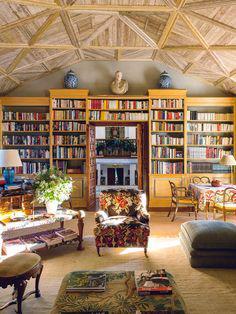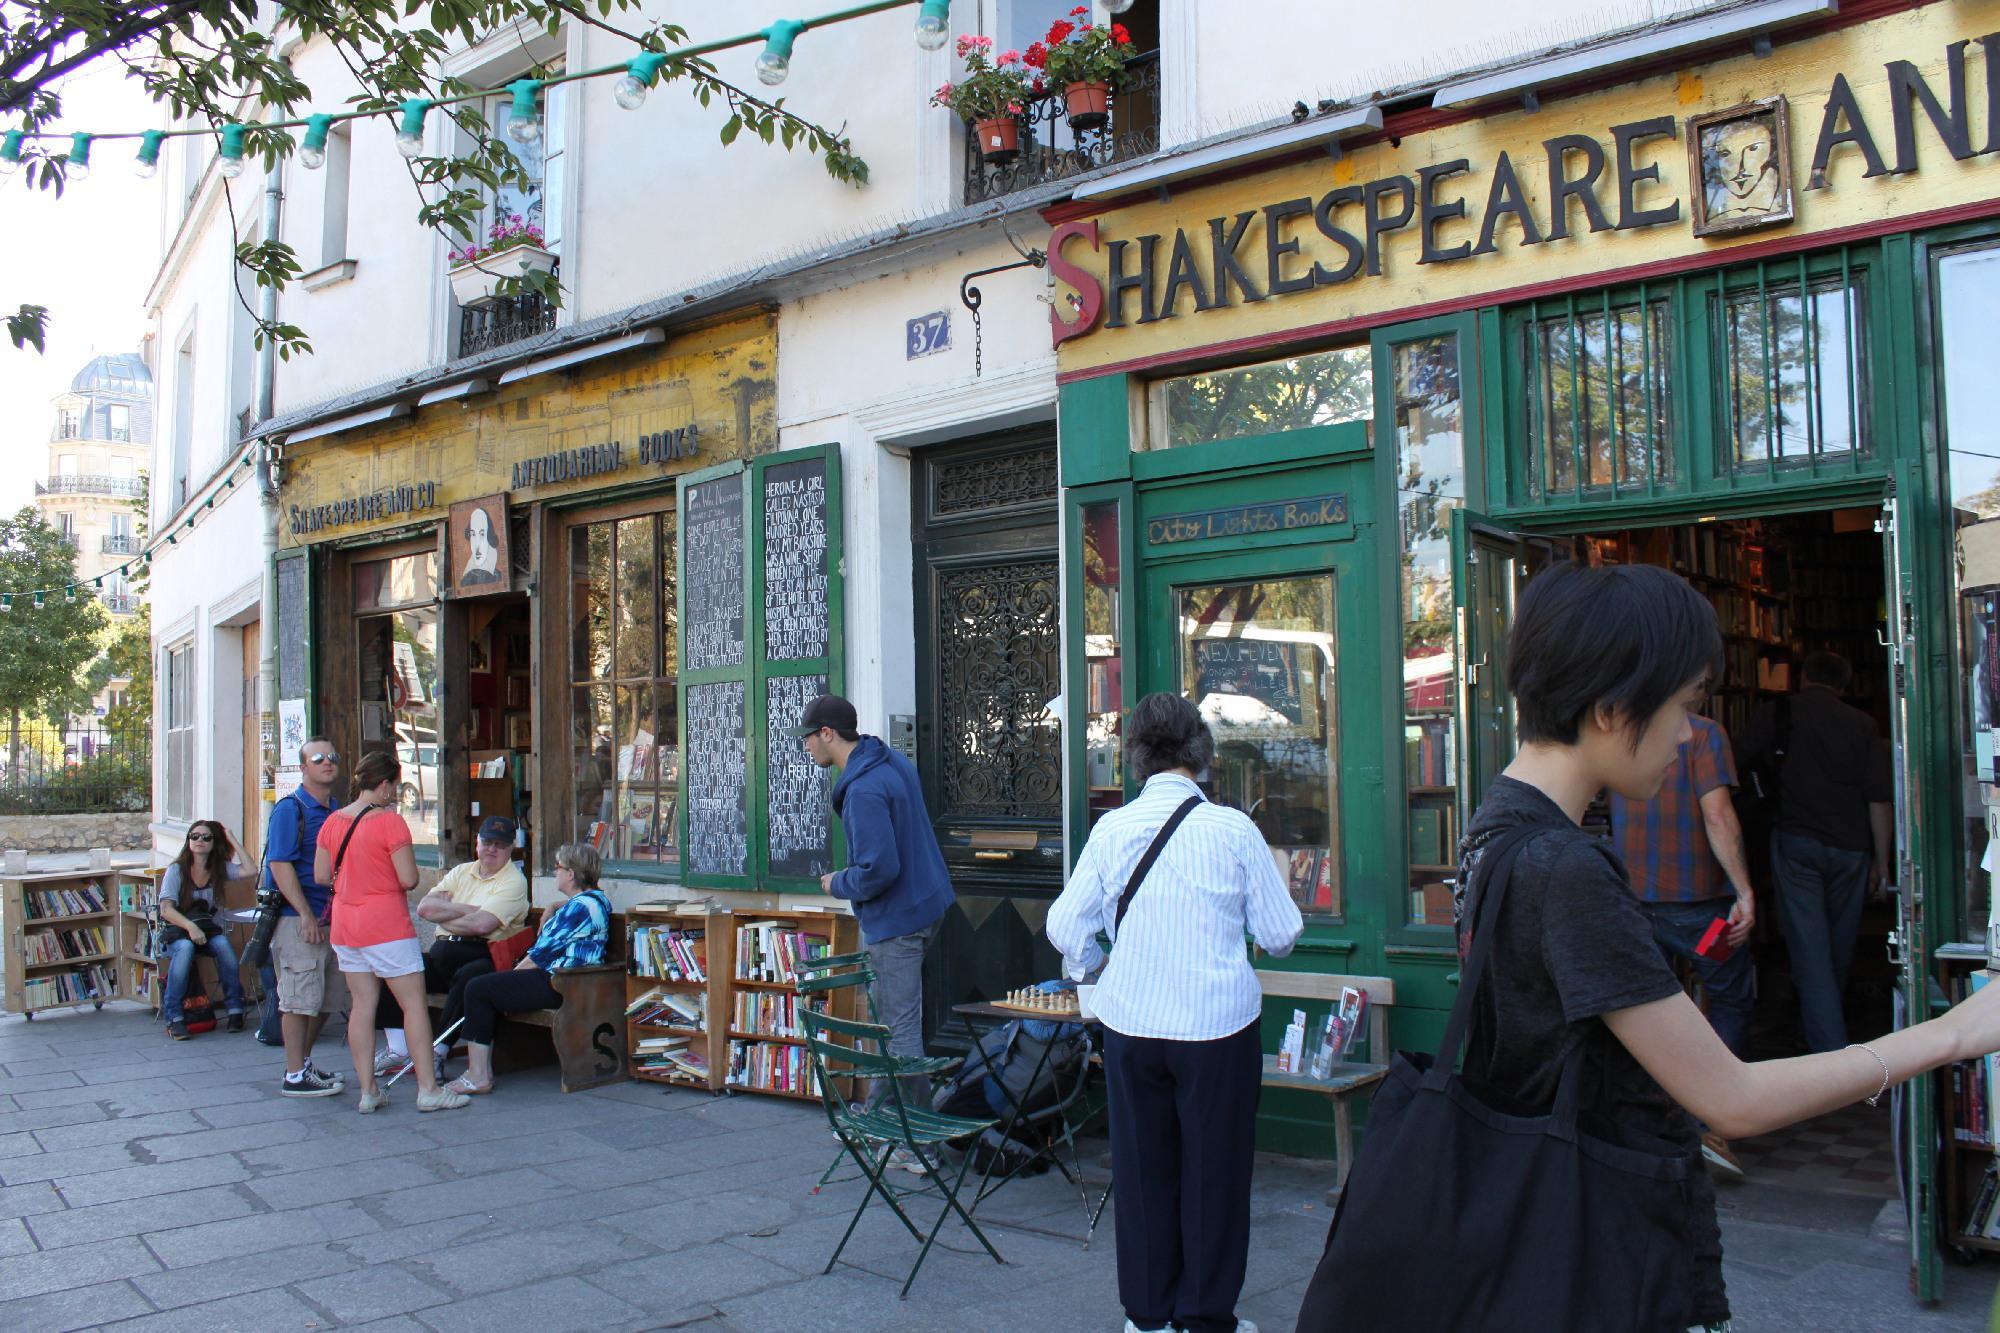The first image is the image on the left, the second image is the image on the right. Analyze the images presented: Is the assertion "There are more than two people at the bookstore in one of the images." valid? Answer yes or no. Yes. The first image is the image on the left, the second image is the image on the right. Evaluate the accuracy of this statement regarding the images: "Crate-like brown bookshelves stand in front of a green bookstore under its yellow sign.". Is it true? Answer yes or no. No. 